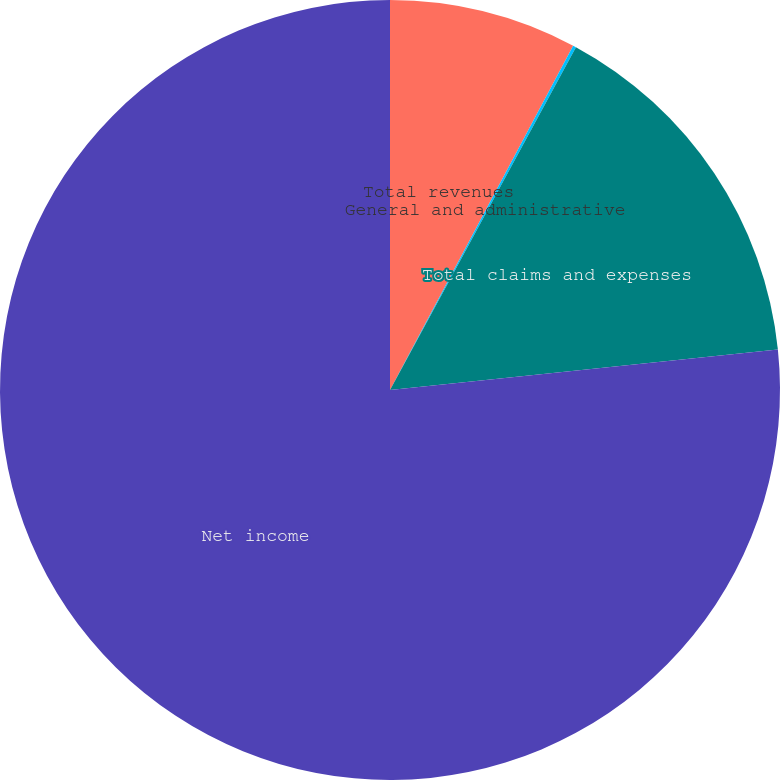<chart> <loc_0><loc_0><loc_500><loc_500><pie_chart><fcel>Total revenues<fcel>General and administrative<fcel>Total claims and expenses<fcel>Net income<nl><fcel>7.78%<fcel>0.13%<fcel>15.43%<fcel>76.66%<nl></chart> 